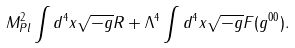<formula> <loc_0><loc_0><loc_500><loc_500>M _ { P l } ^ { 2 } \int d ^ { 4 } x \sqrt { - g } R + \Lambda ^ { 4 } \int d ^ { 4 } x \sqrt { - g } F ( g ^ { 0 0 } ) .</formula> 